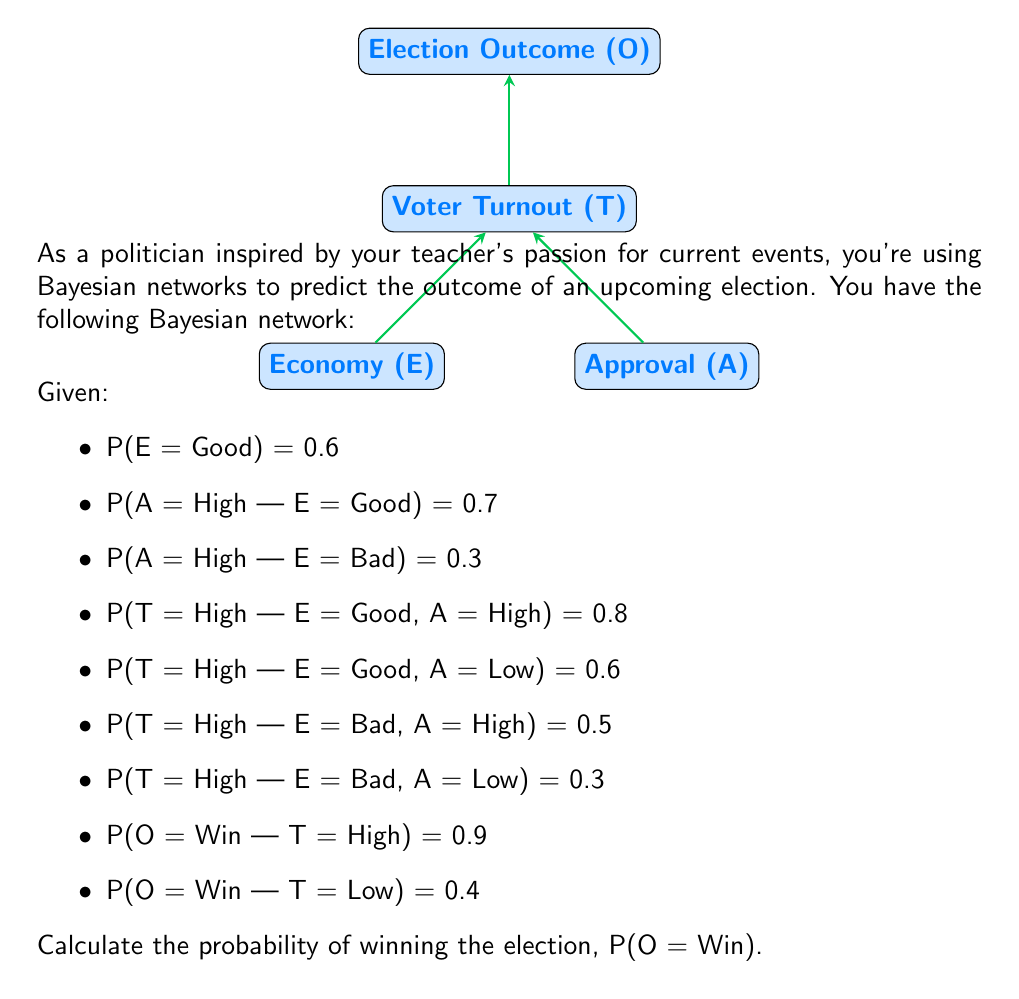Show me your answer to this math problem. To solve this problem, we'll use the law of total probability and Bayesian network principles:

1) First, calculate P(A = High):
   P(A = High) = P(A = High | E = Good) * P(E = Good) + P(A = High | E = Bad) * P(E = Bad)
   = 0.7 * 0.6 + 0.3 * 0.4 = 0.42 + 0.12 = 0.54

2) Now, calculate P(T = High):
   P(T = High) = P(T = High | E = Good, A = High) * P(E = Good) * P(A = High | E = Good)
                + P(T = High | E = Good, A = Low) * P(E = Good) * P(A = Low | E = Good)
                + P(T = High | E = Bad, A = High) * P(E = Bad) * P(A = High | E = Bad)
                + P(T = High | E = Bad, A = Low) * P(E = Bad) * P(A = Low | E = Bad)
   = 0.8 * 0.6 * 0.7 + 0.6 * 0.6 * 0.3 + 0.5 * 0.4 * 0.3 + 0.3 * 0.4 * 0.7
   = 0.336 + 0.108 + 0.06 + 0.084 = 0.588

3) Finally, calculate P(O = Win):
   P(O = Win) = P(O = Win | T = High) * P(T = High) + P(O = Win | T = Low) * P(T = Low)
   = 0.9 * 0.588 + 0.4 * (1 - 0.588)
   = 0.5292 + 0.1648 = 0.694

Therefore, the probability of winning the election is 0.694 or 69.4%.
Answer: 0.694 